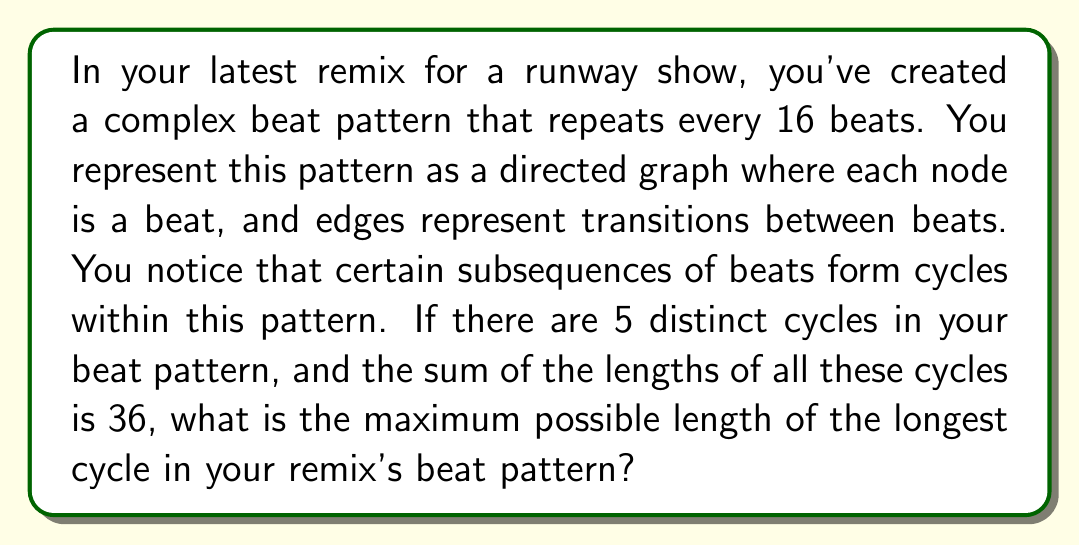Show me your answer to this math problem. Let's approach this step-by-step using graph theory and cycle analysis:

1) We know that there are 5 distinct cycles in the beat pattern, and the total length of all cycles is 36 beats.

2) In graph theory, the length of a cycle is the number of edges (or nodes) in the cycle.

3) To maximize the length of the longest cycle, we need to minimize the lengths of the other cycles.

4) The shortest possible cycle in a directed graph is a self-loop, which has a length of 1.

5) Therefore, to maximize the longest cycle, we should assume that 4 of the 5 cycles are self-loops (length 1 each), and the remaining cycle contains all the other beats.

6) Let $x$ be the length of the longest cycle. We can set up an equation:

   $$4 \cdot 1 + x = 36$$

7) Solving for $x$:

   $$x = 36 - 4 = 32$$

8) We need to verify if this is possible within a 16-beat pattern. Since 32 > 16, this longest cycle would need to visit some beats more than once.

9) In a 16-beat pattern, the maximum possible cycle length would be 16, as it would visit each beat exactly once before repeating.

Therefore, the maximum possible length of the longest cycle is 16 beats.
Answer: 16 beats 